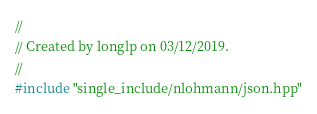<code> <loc_0><loc_0><loc_500><loc_500><_C++_>//
// Created by longlp on 03/12/2019.
//
#include "single_include/nlohmann/json.hpp"
</code> 